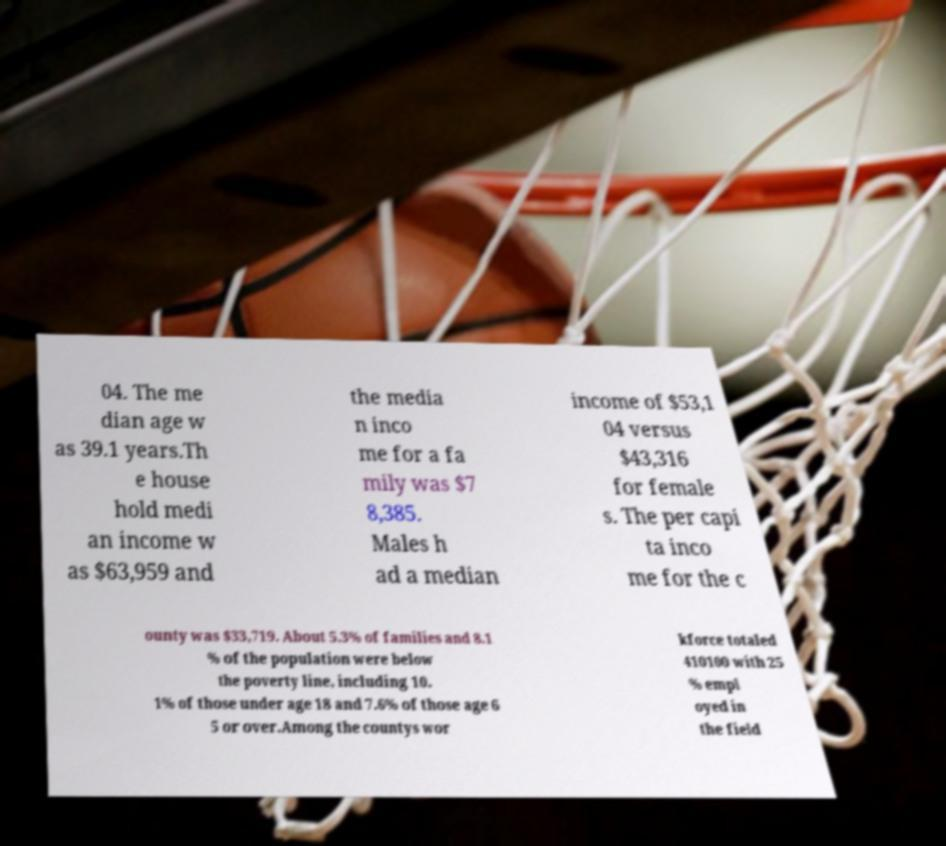There's text embedded in this image that I need extracted. Can you transcribe it verbatim? 04. The me dian age w as 39.1 years.Th e house hold medi an income w as $63,959 and the media n inco me for a fa mily was $7 8,385. Males h ad a median income of $53,1 04 versus $43,316 for female s. The per capi ta inco me for the c ounty was $33,719. About 5.3% of families and 8.1 % of the population were below the poverty line, including 10. 1% of those under age 18 and 7.6% of those age 6 5 or over.Among the countys wor kforce totaled 410100 with 25 % empl oyed in the field 